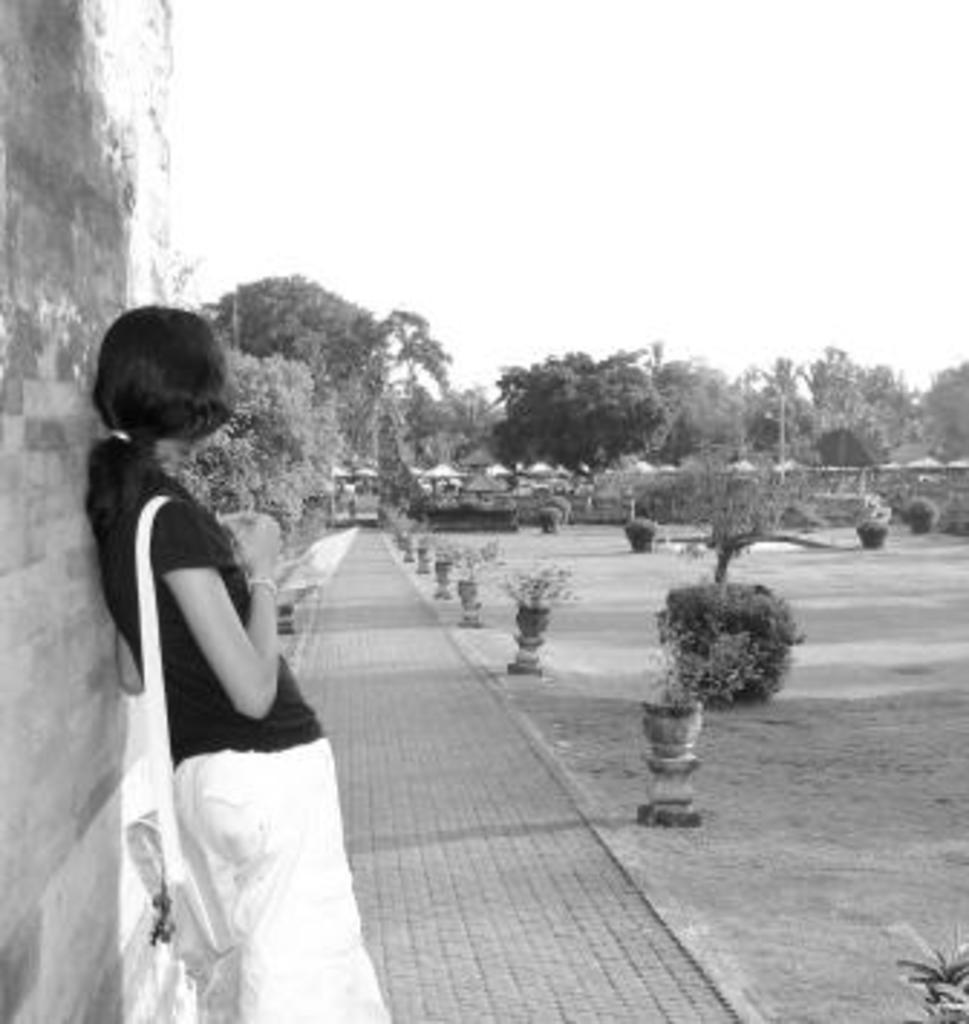Describe this image in one or two sentences. On the left side, there is a woman standing on a footpath and leaning on a wall. On the right side, there are plants and grass. In the background, there are trees, shelters and the sky. 